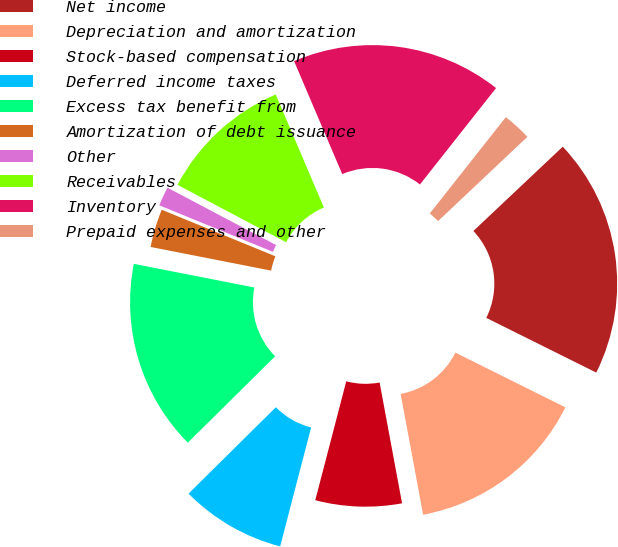<chart> <loc_0><loc_0><loc_500><loc_500><pie_chart><fcel>Net income<fcel>Depreciation and amortization<fcel>Stock-based compensation<fcel>Deferred income taxes<fcel>Excess tax benefit from<fcel>Amortization of debt issuance<fcel>Other<fcel>Receivables<fcel>Inventory<fcel>Prepaid expenses and other<nl><fcel>19.38%<fcel>14.73%<fcel>6.98%<fcel>8.53%<fcel>15.5%<fcel>3.1%<fcel>1.55%<fcel>10.85%<fcel>17.05%<fcel>2.33%<nl></chart> 